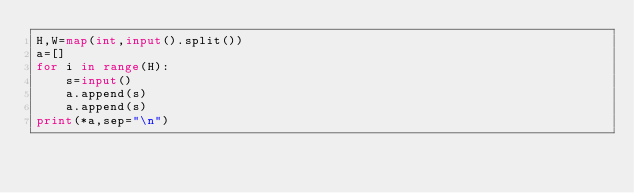<code> <loc_0><loc_0><loc_500><loc_500><_Python_>H,W=map(int,input().split())
a=[]
for i in range(H):
    s=input()
    a.append(s)
    a.append(s)
print(*a,sep="\n")
</code> 